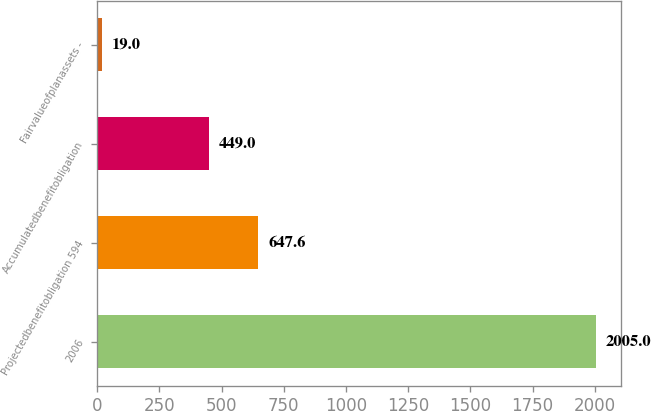<chart> <loc_0><loc_0><loc_500><loc_500><bar_chart><fcel>2006<fcel>Projectedbenefitobligation 594<fcel>Accumulatedbenefitobligation<fcel>Fairvalueofplanassets -<nl><fcel>2005<fcel>647.6<fcel>449<fcel>19<nl></chart> 